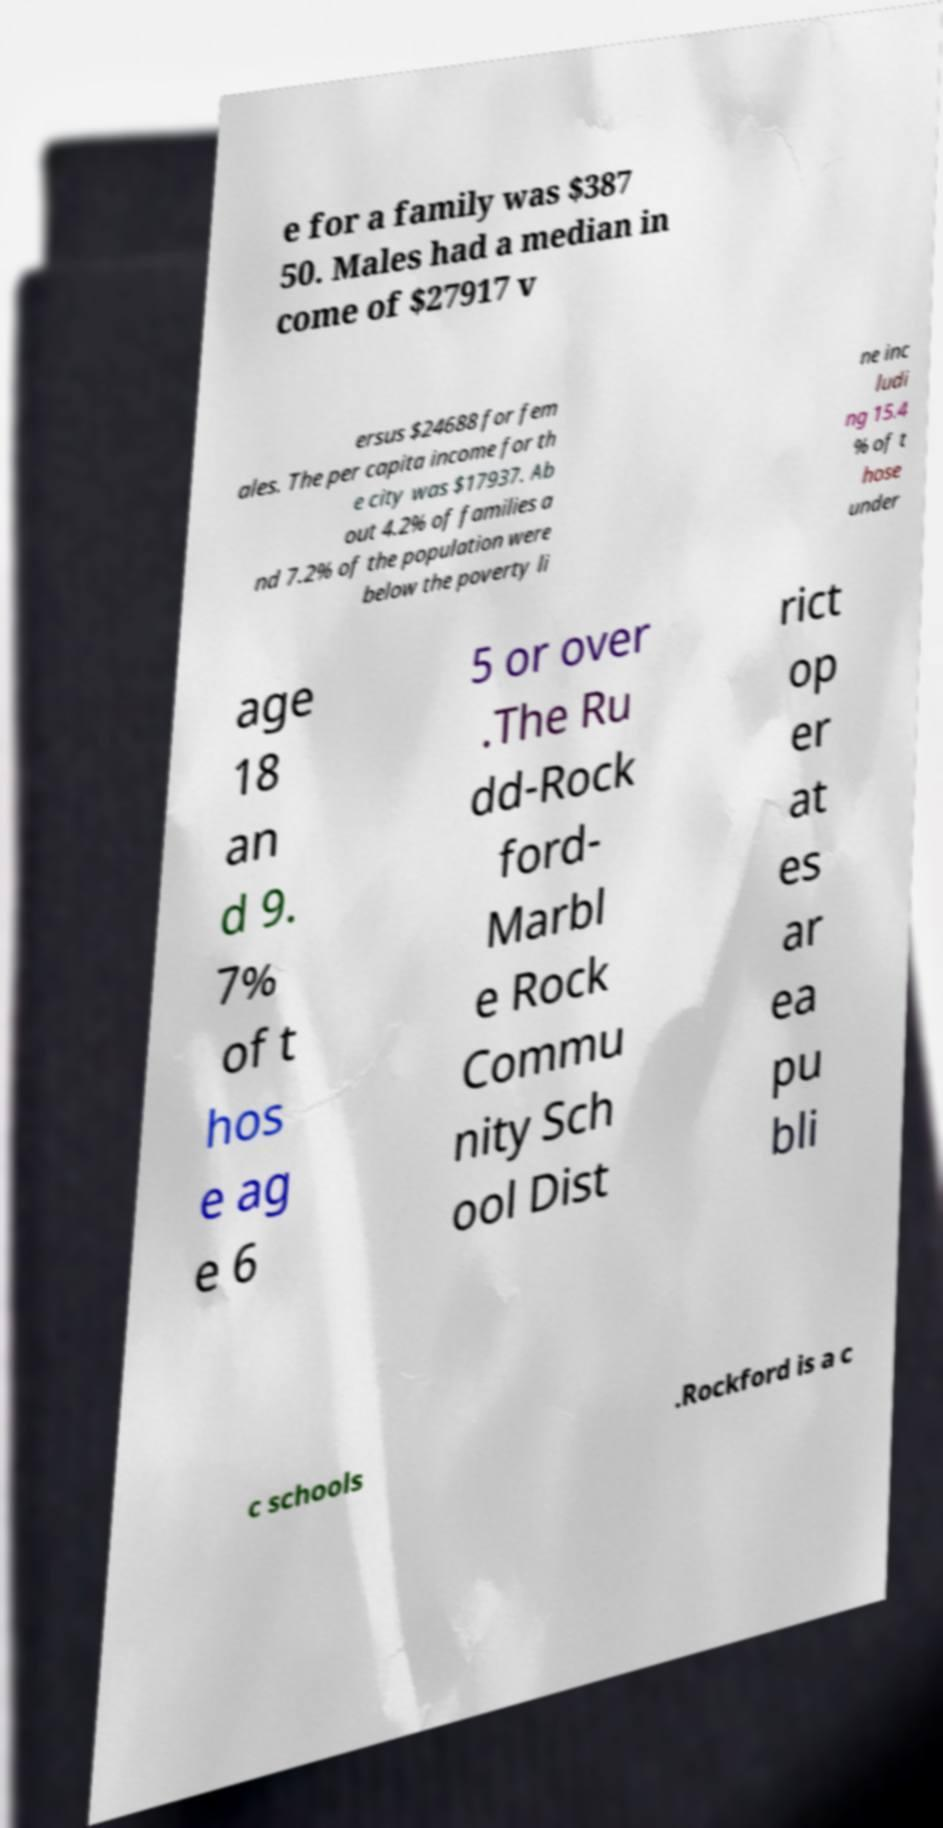Could you assist in decoding the text presented in this image and type it out clearly? e for a family was $387 50. Males had a median in come of $27917 v ersus $24688 for fem ales. The per capita income for th e city was $17937. Ab out 4.2% of families a nd 7.2% of the population were below the poverty li ne inc ludi ng 15.4 % of t hose under age 18 an d 9. 7% of t hos e ag e 6 5 or over .The Ru dd-Rock ford- Marbl e Rock Commu nity Sch ool Dist rict op er at es ar ea pu bli c schools .Rockford is a c 